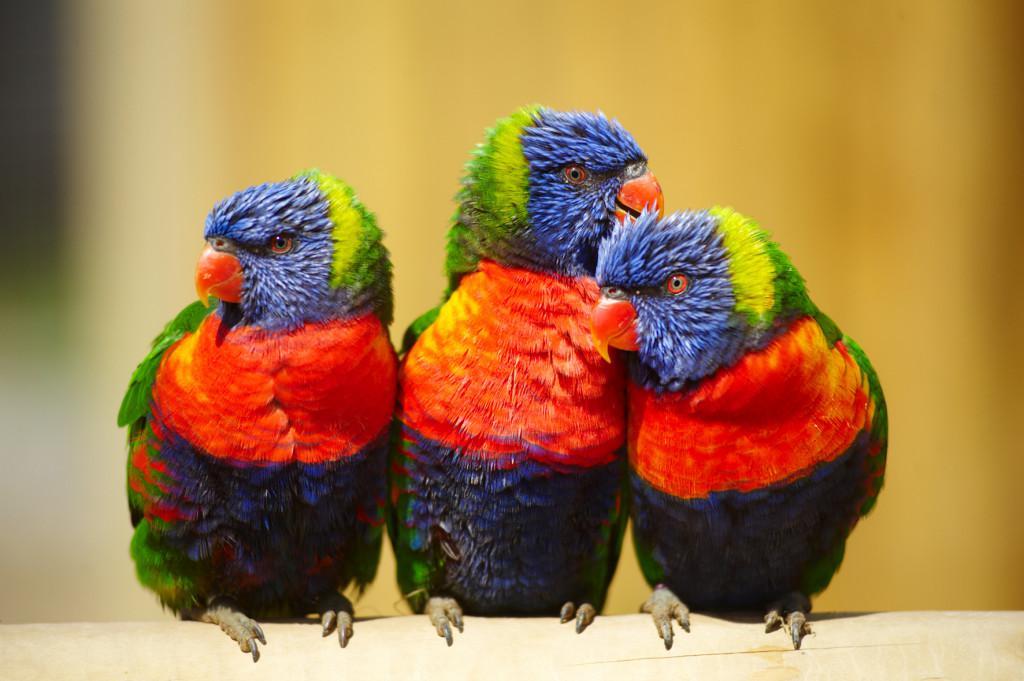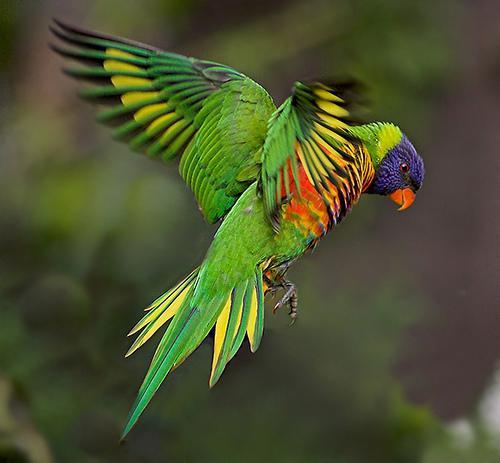The first image is the image on the left, the second image is the image on the right. Considering the images on both sides, is "There is no more than two parrots." valid? Answer yes or no. No. 